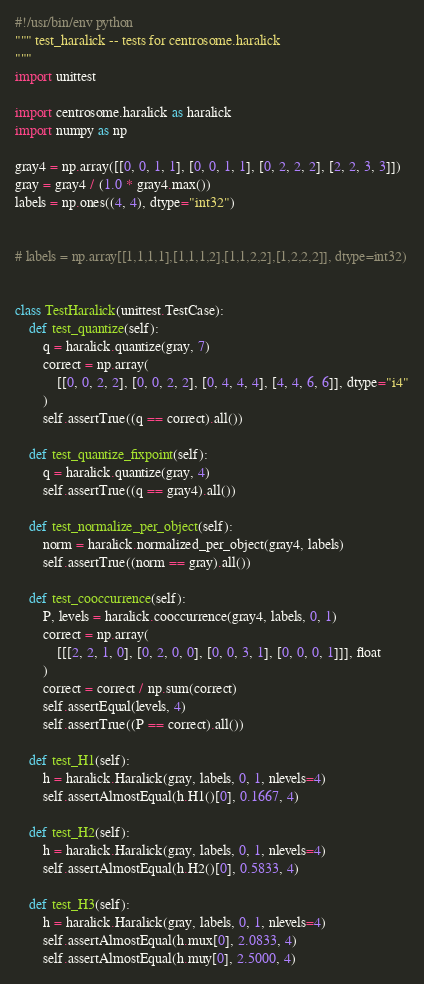<code> <loc_0><loc_0><loc_500><loc_500><_Python_>#!/usr/bin/env python
""" test_haralick -- tests for centrosome.haralick
"""
import unittest

import centrosome.haralick as haralick
import numpy as np

gray4 = np.array([[0, 0, 1, 1], [0, 0, 1, 1], [0, 2, 2, 2], [2, 2, 3, 3]])
gray = gray4 / (1.0 * gray4.max())
labels = np.ones((4, 4), dtype="int32")


# labels = np.array[[1,1,1,1],[1,1,1,2],[1,1,2,2],[1,2,2,2]], dtype=int32)


class TestHaralick(unittest.TestCase):
    def test_quantize(self):
        q = haralick.quantize(gray, 7)
        correct = np.array(
            [[0, 0, 2, 2], [0, 0, 2, 2], [0, 4, 4, 4], [4, 4, 6, 6]], dtype="i4"
        )
        self.assertTrue((q == correct).all())

    def test_quantize_fixpoint(self):
        q = haralick.quantize(gray, 4)
        self.assertTrue((q == gray4).all())

    def test_normalize_per_object(self):
        norm = haralick.normalized_per_object(gray4, labels)
        self.assertTrue((norm == gray).all())

    def test_cooccurrence(self):
        P, levels = haralick.cooccurrence(gray4, labels, 0, 1)
        correct = np.array(
            [[[2, 2, 1, 0], [0, 2, 0, 0], [0, 0, 3, 1], [0, 0, 0, 1]]], float
        )
        correct = correct / np.sum(correct)
        self.assertEqual(levels, 4)
        self.assertTrue((P == correct).all())

    def test_H1(self):
        h = haralick.Haralick(gray, labels, 0, 1, nlevels=4)
        self.assertAlmostEqual(h.H1()[0], 0.1667, 4)

    def test_H2(self):
        h = haralick.Haralick(gray, labels, 0, 1, nlevels=4)
        self.assertAlmostEqual(h.H2()[0], 0.5833, 4)

    def test_H3(self):
        h = haralick.Haralick(gray, labels, 0, 1, nlevels=4)
        self.assertAlmostEqual(h.mux[0], 2.0833, 4)
        self.assertAlmostEqual(h.muy[0], 2.5000, 4)</code> 